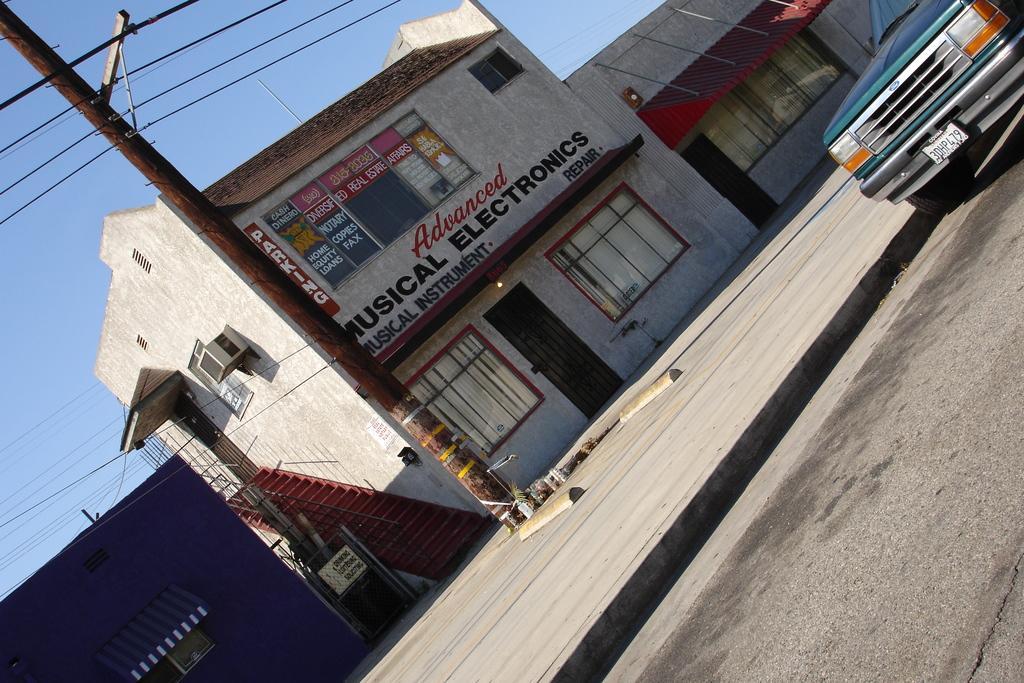Could you give a brief overview of what you see in this image? In the picture we can see a road on it, we can see a car and beside it, we can see a path and a poll on it and some wires to it and we can also see some houses with doors, windows and steps and besides to it, we can see some other houses which are blue and some house with a glass window and we can also see a sky. 